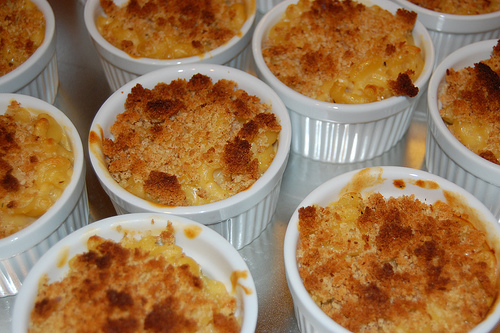<image>
Is the cake in the cup? No. The cake is not contained within the cup. These objects have a different spatial relationship. 